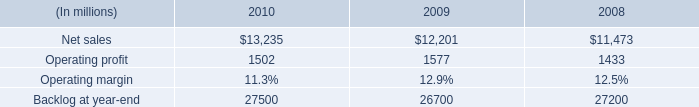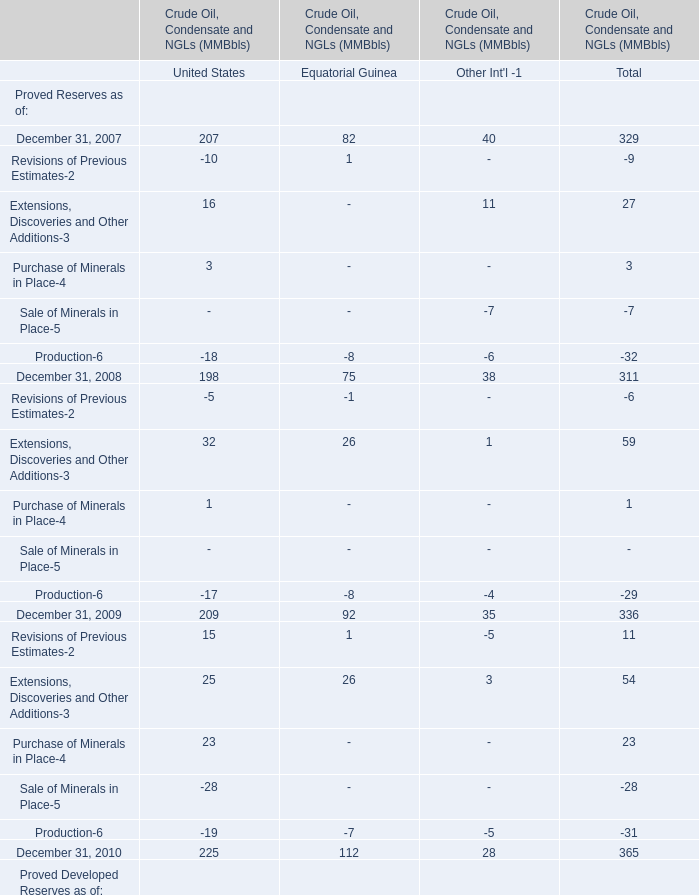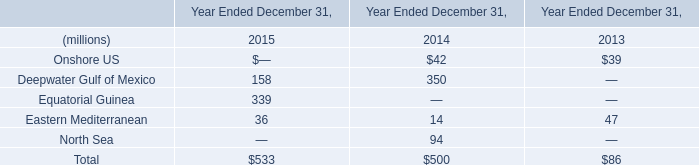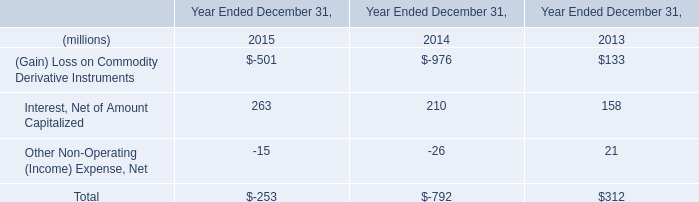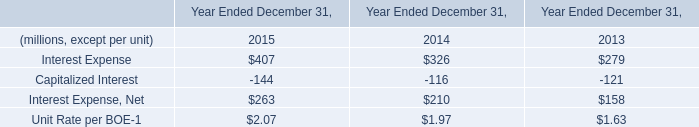What is the sum of Extensions, Discoveries and Other Additions-3 of United States in 2008 and Deepwater Gulf of Mexico in 2014?? (in million) 
Computations: (32 + 350)
Answer: 382.0. 